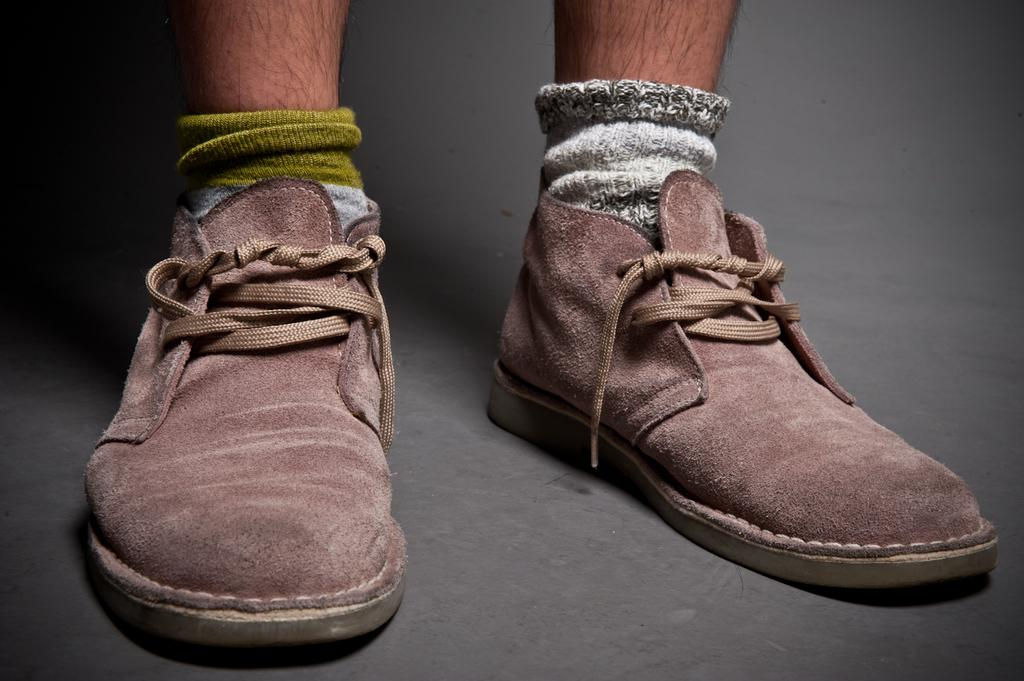What part of a person can be seen in the image? There is a leg of a person in the image. What type of footwear is the person wearing? The person is wearing shoes. Are there any additional accessories on the shoes? Yes, there are laces on the shoes. What clothing item is worn underneath the shoes? The person is wearing socks. Is there an umbrella being held by the person in the image? There is no umbrella present in the image. Can you see the person's hand holding the leg in the image? The image only shows a leg, and there is no hand visible. --- Facts: 1. There is a car in the image. 2. The car is red. 3. The car has four wheels. 4. There is a road in the image. 5. The road is paved. Absurd Topics: ocean, bird, mountain Conversation: What type of vehicle is in the image? There is a car in the image. What color is the car? The car is red. How many wheels does the car have? The car has four wheels. What type of surface is the car on in the image? There is a road in the image, and it is paved. Reasoning: Let's think step by step in order to produce the conversation. We start by identifying the main subject in the image, which is the car. Then, we expand the conversation to include details about the car's color and number of wheels. Finally, we describe the surface the car is on, which is a paved road. Each question is designed to elicit a specific detail about the image that is known from the provided facts. Absurd Question/Answer: Can you see any mountains in the background of the image? There are no mountains visible in the image; it only shows a car and a paved road. Is there a bird flying over the car in the image? There is no bird present in the image. 